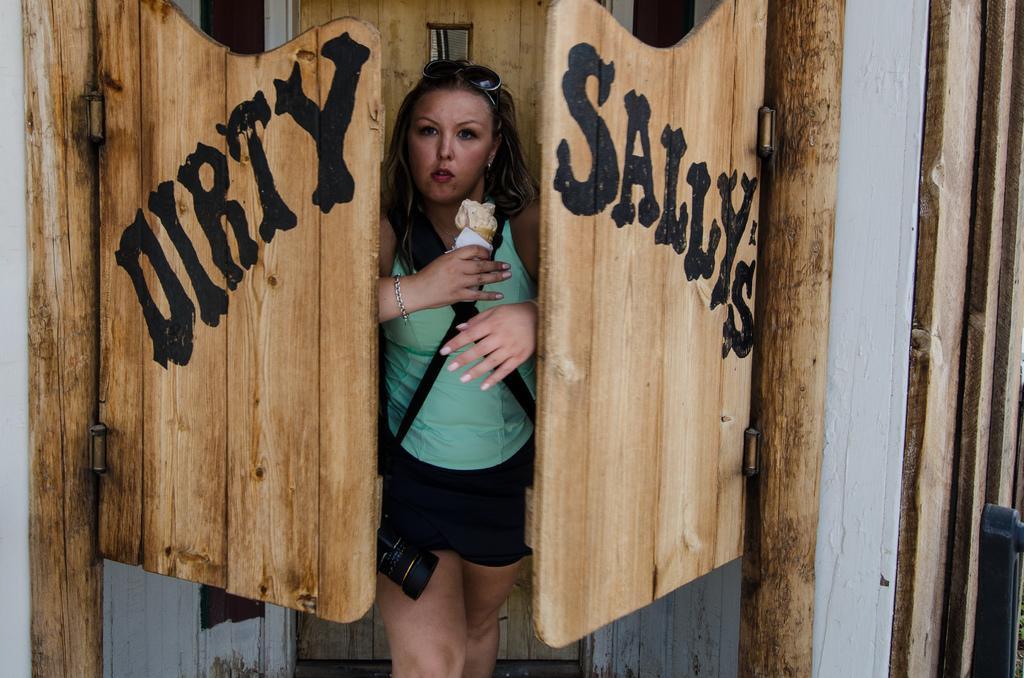How would you summarize this image in a sentence or two? In this picture there is a woman who is wearing goggle, t-shirt, short and she is holding a ice cream and camera. Beside her we can see the doors. In the back there's another door near to the wall. 